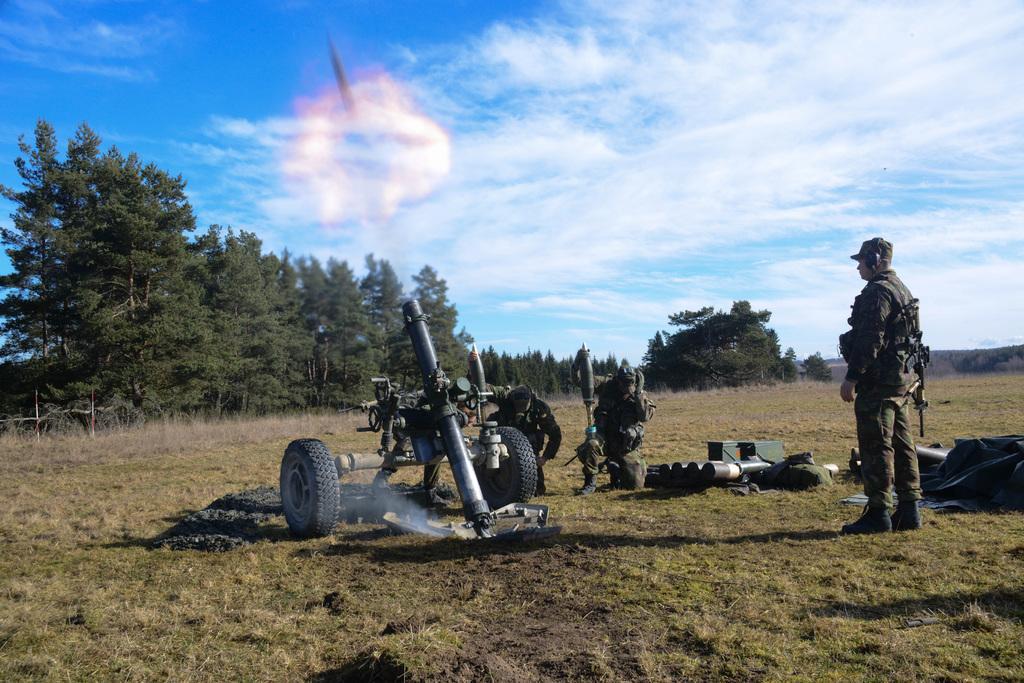In one or two sentences, can you explain what this image depicts? In this image we can see one cannon on the ground, some smoke near the cannon, some objects on the ground, two poles, two army men in kneeling position holding objects, one army man standing and wearing objects. It looks like mountains in the background on the right side of the image, some trees and grass on the ground. It looks like one object with light in the sky and at the top there is the cloudy sky. 